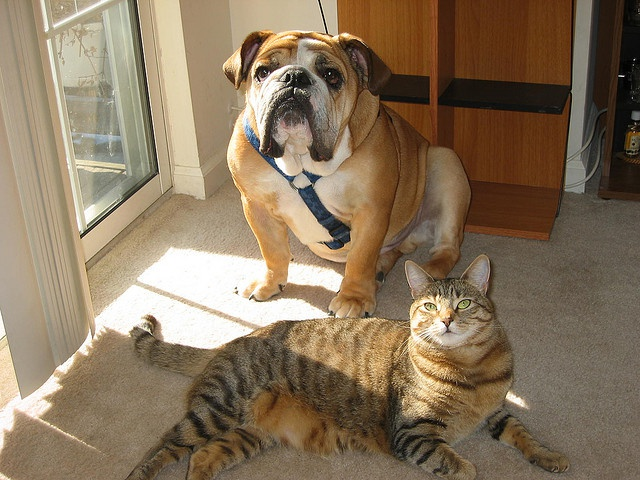Describe the objects in this image and their specific colors. I can see cat in gray, maroon, and black tones, dog in gray, maroon, tan, and black tones, and bottle in gray, black, olive, and maroon tones in this image. 